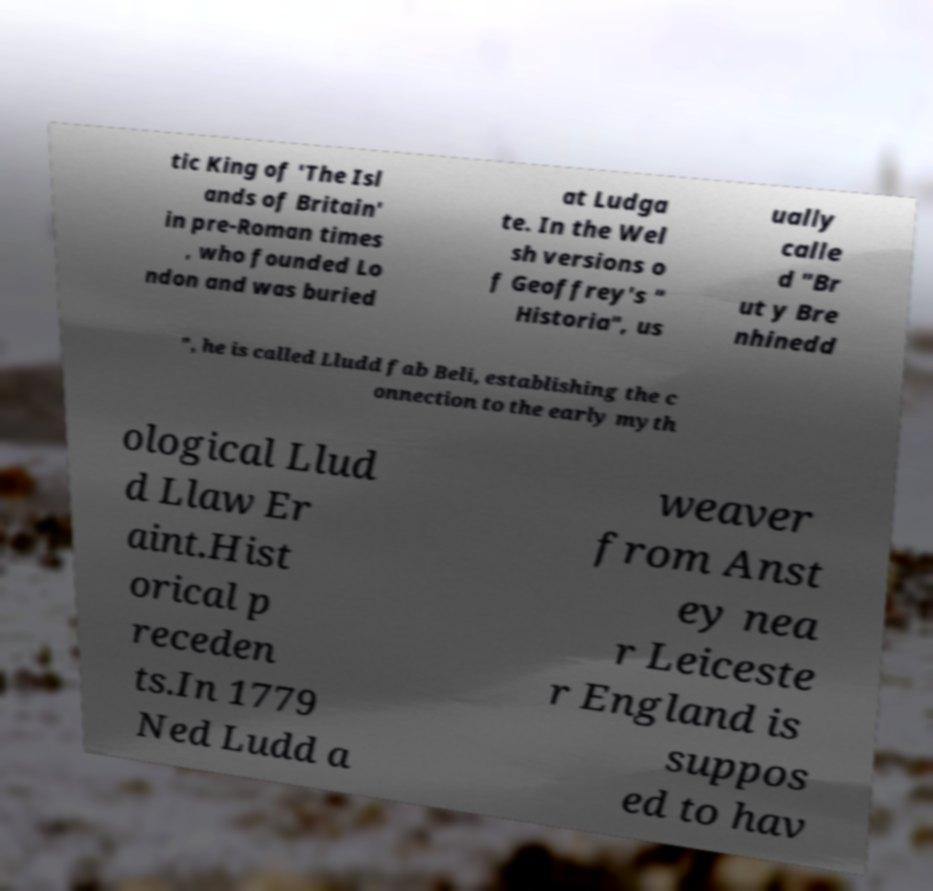Could you extract and type out the text from this image? tic King of 'The Isl ands of Britain' in pre-Roman times , who founded Lo ndon and was buried at Ludga te. In the Wel sh versions o f Geoffrey's " Historia", us ually calle d "Br ut y Bre nhinedd ", he is called Lludd fab Beli, establishing the c onnection to the early myth ological Llud d Llaw Er aint.Hist orical p receden ts.In 1779 Ned Ludd a weaver from Anst ey nea r Leiceste r England is suppos ed to hav 